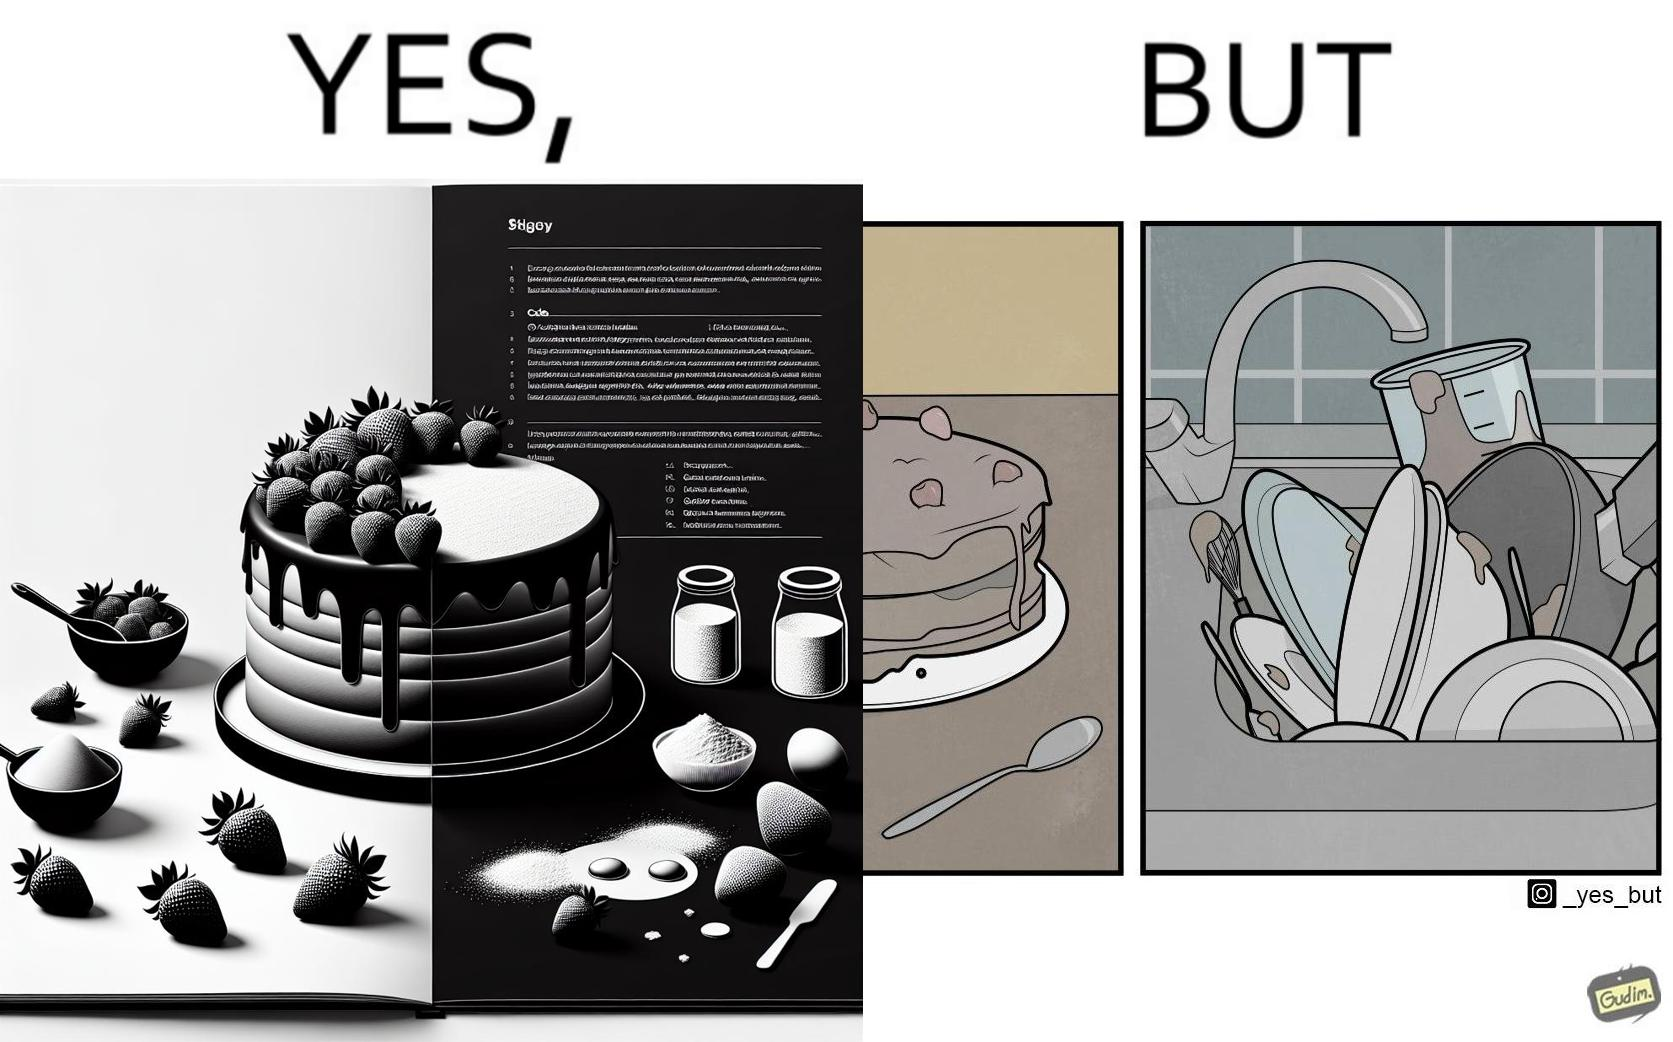Is this image satirical or non-satirical? Yes, this image is satirical. 